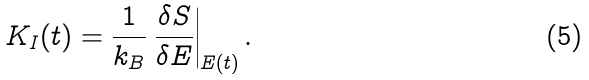Convert formula to latex. <formula><loc_0><loc_0><loc_500><loc_500>K _ { I } ( t ) = \frac { 1 } { k _ { B } } \left . \frac { \delta S } { \delta E } \right | _ { E ( t ) } .</formula> 